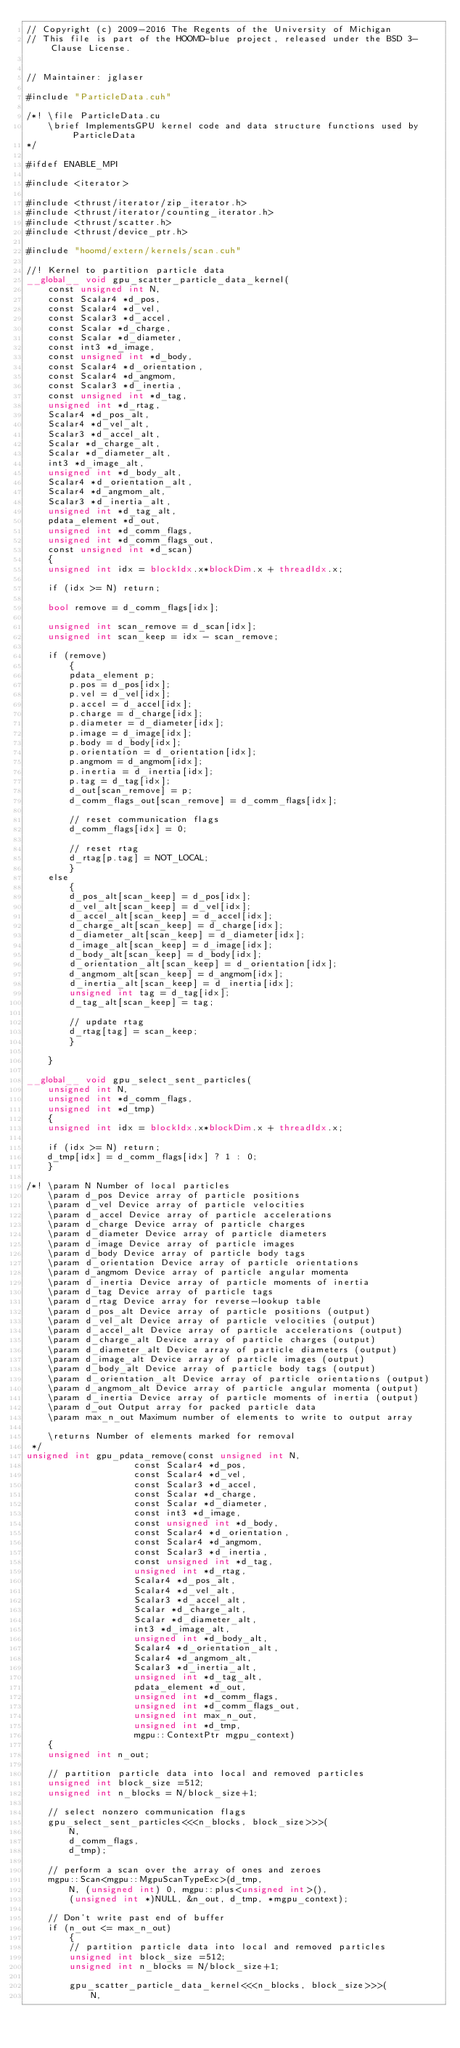Convert code to text. <code><loc_0><loc_0><loc_500><loc_500><_Cuda_>// Copyright (c) 2009-2016 The Regents of the University of Michigan
// This file is part of the HOOMD-blue project, released under the BSD 3-Clause License.


// Maintainer: jglaser

#include "ParticleData.cuh"

/*! \file ParticleData.cu
    \brief ImplementsGPU kernel code and data structure functions used by ParticleData
*/

#ifdef ENABLE_MPI

#include <iterator>

#include <thrust/iterator/zip_iterator.h>
#include <thrust/iterator/counting_iterator.h>
#include <thrust/scatter.h>
#include <thrust/device_ptr.h>

#include "hoomd/extern/kernels/scan.cuh"

//! Kernel to partition particle data
__global__ void gpu_scatter_particle_data_kernel(
    const unsigned int N,
    const Scalar4 *d_pos,
    const Scalar4 *d_vel,
    const Scalar3 *d_accel,
    const Scalar *d_charge,
    const Scalar *d_diameter,
    const int3 *d_image,
    const unsigned int *d_body,
    const Scalar4 *d_orientation,
    const Scalar4 *d_angmom,
    const Scalar3 *d_inertia,
    const unsigned int *d_tag,
    unsigned int *d_rtag,
    Scalar4 *d_pos_alt,
    Scalar4 *d_vel_alt,
    Scalar3 *d_accel_alt,
    Scalar *d_charge_alt,
    Scalar *d_diameter_alt,
    int3 *d_image_alt,
    unsigned int *d_body_alt,
    Scalar4 *d_orientation_alt,
    Scalar4 *d_angmom_alt,
    Scalar3 *d_inertia_alt,
    unsigned int *d_tag_alt,
    pdata_element *d_out,
    unsigned int *d_comm_flags,
    unsigned int *d_comm_flags_out,
    const unsigned int *d_scan)
    {
    unsigned int idx = blockIdx.x*blockDim.x + threadIdx.x;

    if (idx >= N) return;

    bool remove = d_comm_flags[idx];

    unsigned int scan_remove = d_scan[idx];
    unsigned int scan_keep = idx - scan_remove;

    if (remove)
        {
        pdata_element p;
        p.pos = d_pos[idx];
        p.vel = d_vel[idx];
        p.accel = d_accel[idx];
        p.charge = d_charge[idx];
        p.diameter = d_diameter[idx];
        p.image = d_image[idx];
        p.body = d_body[idx];
        p.orientation = d_orientation[idx];
        p.angmom = d_angmom[idx];
        p.inertia = d_inertia[idx];
        p.tag = d_tag[idx];
        d_out[scan_remove] = p;
        d_comm_flags_out[scan_remove] = d_comm_flags[idx];

        // reset communication flags
        d_comm_flags[idx] = 0;

        // reset rtag
        d_rtag[p.tag] = NOT_LOCAL;
        }
    else
        {
        d_pos_alt[scan_keep] = d_pos[idx];
        d_vel_alt[scan_keep] = d_vel[idx];
        d_accel_alt[scan_keep] = d_accel[idx];
        d_charge_alt[scan_keep] = d_charge[idx];
        d_diameter_alt[scan_keep] = d_diameter[idx];
        d_image_alt[scan_keep] = d_image[idx];
        d_body_alt[scan_keep] = d_body[idx];
        d_orientation_alt[scan_keep] = d_orientation[idx];
        d_angmom_alt[scan_keep] = d_angmom[idx];
        d_inertia_alt[scan_keep] = d_inertia[idx];
        unsigned int tag = d_tag[idx];
        d_tag_alt[scan_keep] = tag;

        // update rtag
        d_rtag[tag] = scan_keep;
        }

    }

__global__ void gpu_select_sent_particles(
    unsigned int N,
    unsigned int *d_comm_flags,
    unsigned int *d_tmp)
    {
    unsigned int idx = blockIdx.x*blockDim.x + threadIdx.x;

    if (idx >= N) return;
    d_tmp[idx] = d_comm_flags[idx] ? 1 : 0;
    }

/*! \param N Number of local particles
    \param d_pos Device array of particle positions
    \param d_vel Device array of particle velocities
    \param d_accel Device array of particle accelerations
    \param d_charge Device array of particle charges
    \param d_diameter Device array of particle diameters
    \param d_image Device array of particle images
    \param d_body Device array of particle body tags
    \param d_orientation Device array of particle orientations
    \param d_angmom Device array of particle angular momenta
    \param d_inertia Device array of particle moments of inertia
    \param d_tag Device array of particle tags
    \param d_rtag Device array for reverse-lookup table
    \param d_pos_alt Device array of particle positions (output)
    \param d_vel_alt Device array of particle velocities (output)
    \param d_accel_alt Device array of particle accelerations (output)
    \param d_charge_alt Device array of particle charges (output)
    \param d_diameter_alt Device array of particle diameters (output)
    \param d_image_alt Device array of particle images (output)
    \param d_body_alt Device array of particle body tags (output)
    \param d_orientation_alt Device array of particle orientations (output)
    \param d_angmom_alt Device array of particle angular momenta (output)
    \param d_inertia Device array of particle moments of inertia (output)
    \param d_out Output array for packed particle data
    \param max_n_out Maximum number of elements to write to output array

    \returns Number of elements marked for removal
 */
unsigned int gpu_pdata_remove(const unsigned int N,
                    const Scalar4 *d_pos,
                    const Scalar4 *d_vel,
                    const Scalar3 *d_accel,
                    const Scalar *d_charge,
                    const Scalar *d_diameter,
                    const int3 *d_image,
                    const unsigned int *d_body,
                    const Scalar4 *d_orientation,
                    const Scalar4 *d_angmom,
                    const Scalar3 *d_inertia,
                    const unsigned int *d_tag,
                    unsigned int *d_rtag,
                    Scalar4 *d_pos_alt,
                    Scalar4 *d_vel_alt,
                    Scalar3 *d_accel_alt,
                    Scalar *d_charge_alt,
                    Scalar *d_diameter_alt,
                    int3 *d_image_alt,
                    unsigned int *d_body_alt,
                    Scalar4 *d_orientation_alt,
                    Scalar4 *d_angmom_alt,
                    Scalar3 *d_inertia_alt,
                    unsigned int *d_tag_alt,
                    pdata_element *d_out,
                    unsigned int *d_comm_flags,
                    unsigned int *d_comm_flags_out,
                    unsigned int max_n_out,
                    unsigned int *d_tmp,
                    mgpu::ContextPtr mgpu_context)
    {
    unsigned int n_out;

    // partition particle data into local and removed particles
    unsigned int block_size =512;
    unsigned int n_blocks = N/block_size+1;

    // select nonzero communication flags
    gpu_select_sent_particles<<<n_blocks, block_size>>>(
        N,
        d_comm_flags,
        d_tmp);

    // perform a scan over the array of ones and zeroes
    mgpu::Scan<mgpu::MgpuScanTypeExc>(d_tmp,
        N, (unsigned int) 0, mgpu::plus<unsigned int>(),
        (unsigned int *)NULL, &n_out, d_tmp, *mgpu_context);

    // Don't write past end of buffer
    if (n_out <= max_n_out)
        {
        // partition particle data into local and removed particles
        unsigned int block_size =512;
        unsigned int n_blocks = N/block_size+1;

        gpu_scatter_particle_data_kernel<<<n_blocks, block_size>>>(
            N,</code> 